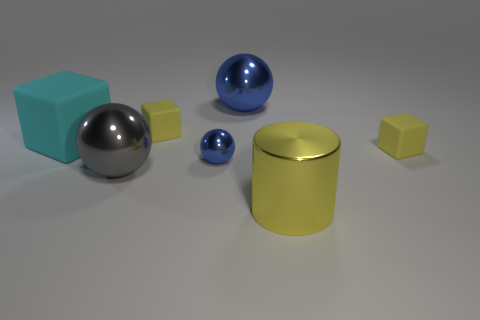What is the material of the yellow thing in front of the small rubber cube to the right of the cylinder?
Your response must be concise. Metal. Are there any blocks that are left of the yellow matte object on the right side of the yellow shiny object?
Offer a very short reply. Yes. There is a yellow object to the right of the metal cylinder; what shape is it?
Provide a short and direct response. Cube. What number of yellow rubber cubes are in front of the big metallic ball that is in front of the blue metallic thing that is in front of the big blue shiny sphere?
Keep it short and to the point. 0. There is a gray ball; is it the same size as the rubber cube that is right of the cylinder?
Your answer should be compact. No. What size is the blue metallic thing that is left of the blue metallic ball that is right of the small blue shiny ball?
Your answer should be compact. Small. What number of yellow objects are the same material as the big cyan block?
Your response must be concise. 2. Are any large spheres visible?
Keep it short and to the point. Yes. There is a matte object that is on the right side of the small sphere; what is its size?
Your answer should be very brief. Small. How many rubber things are the same color as the big shiny cylinder?
Provide a succinct answer. 2. 